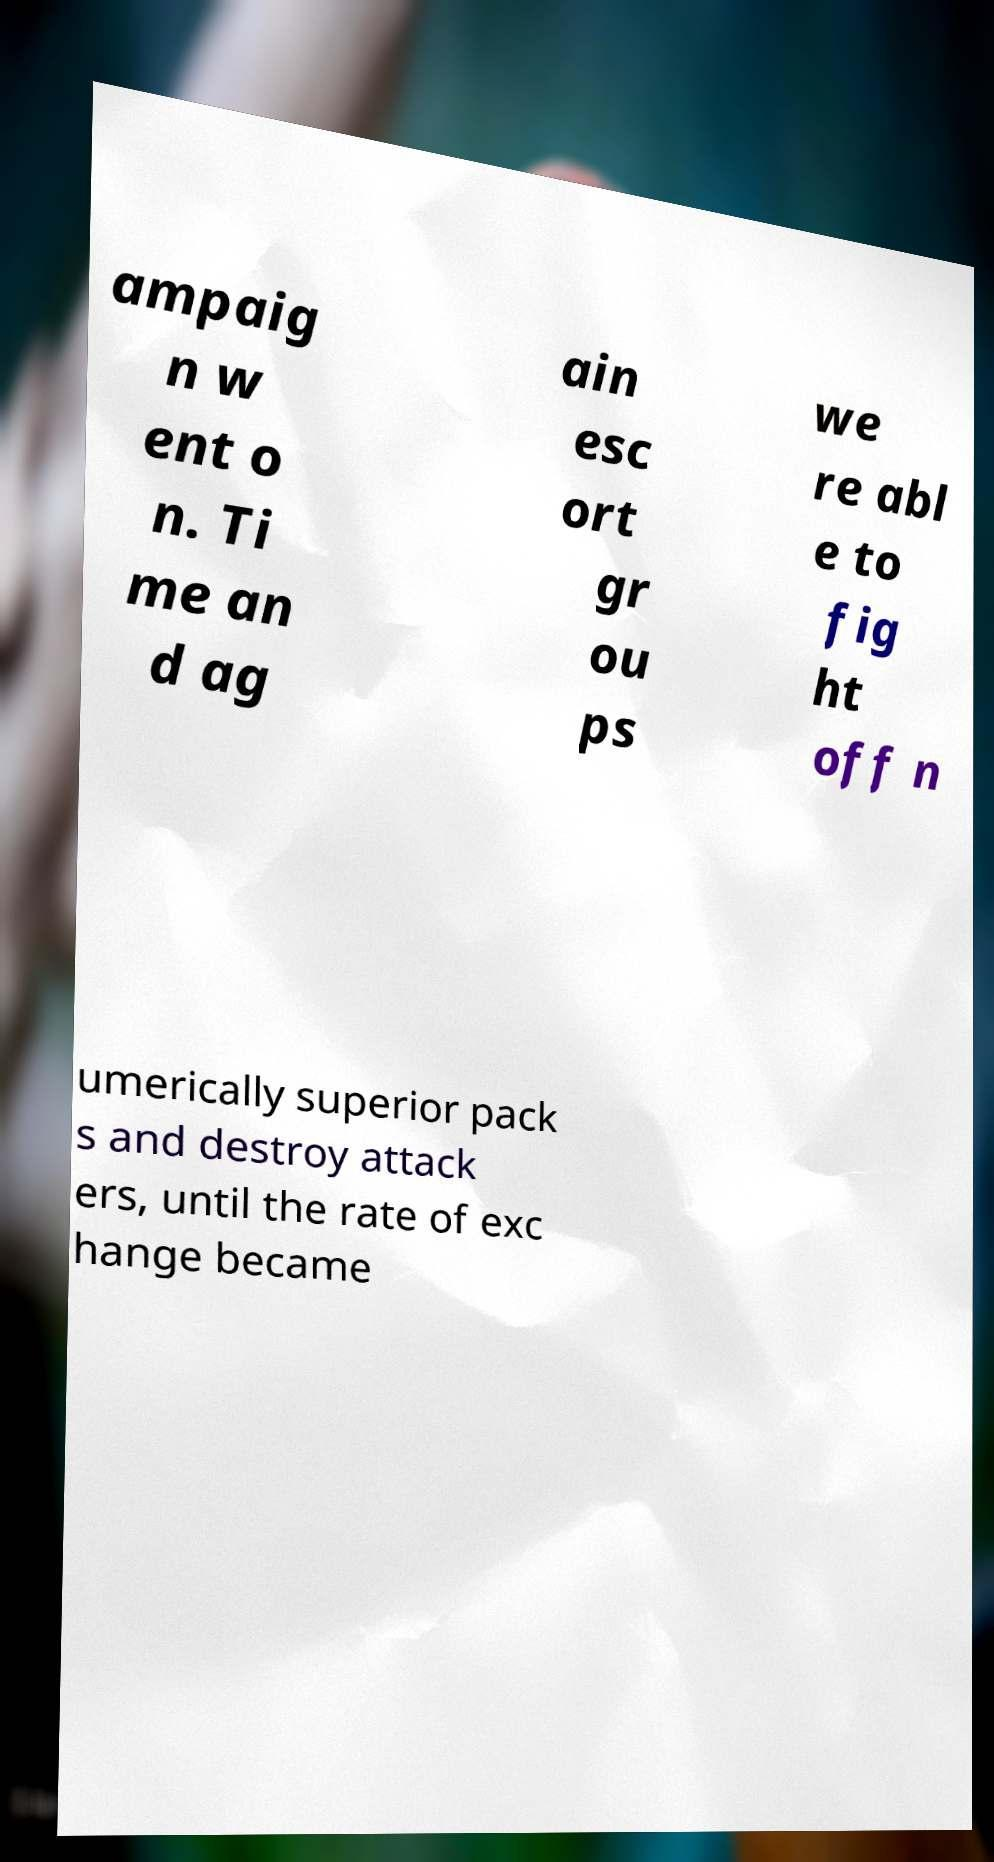Could you assist in decoding the text presented in this image and type it out clearly? ampaig n w ent o n. Ti me an d ag ain esc ort gr ou ps we re abl e to fig ht off n umerically superior pack s and destroy attack ers, until the rate of exc hange became 